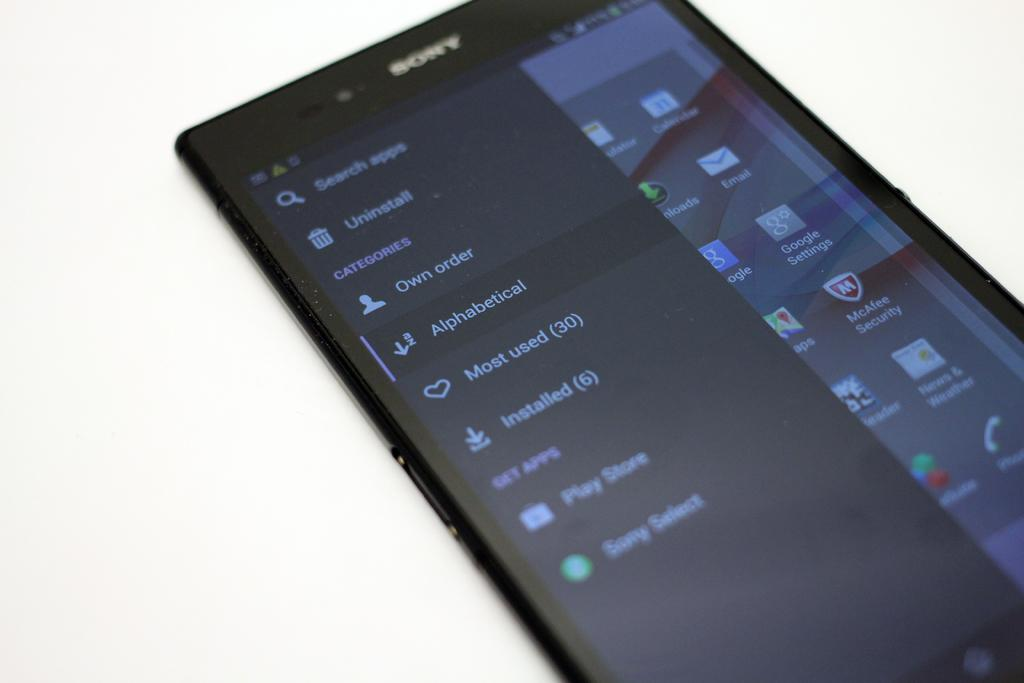<image>
Summarize the visual content of the image. On a sony smartphone a search is made for apps in alphabetical order. 